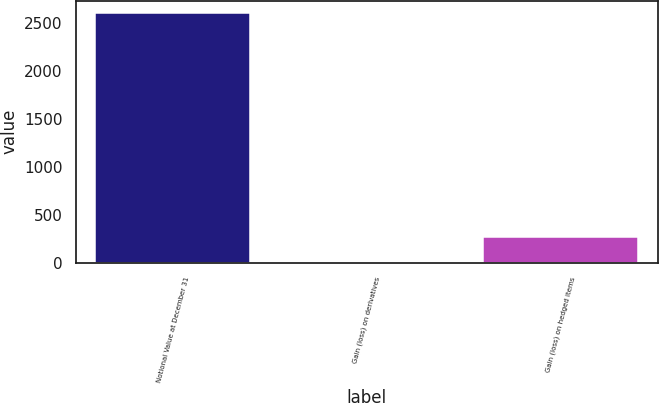<chart> <loc_0><loc_0><loc_500><loc_500><bar_chart><fcel>Notional Value at December 31<fcel>Gain (loss) on derivatives<fcel>Gain (loss) on hedged items<nl><fcel>2601<fcel>5<fcel>264.6<nl></chart> 